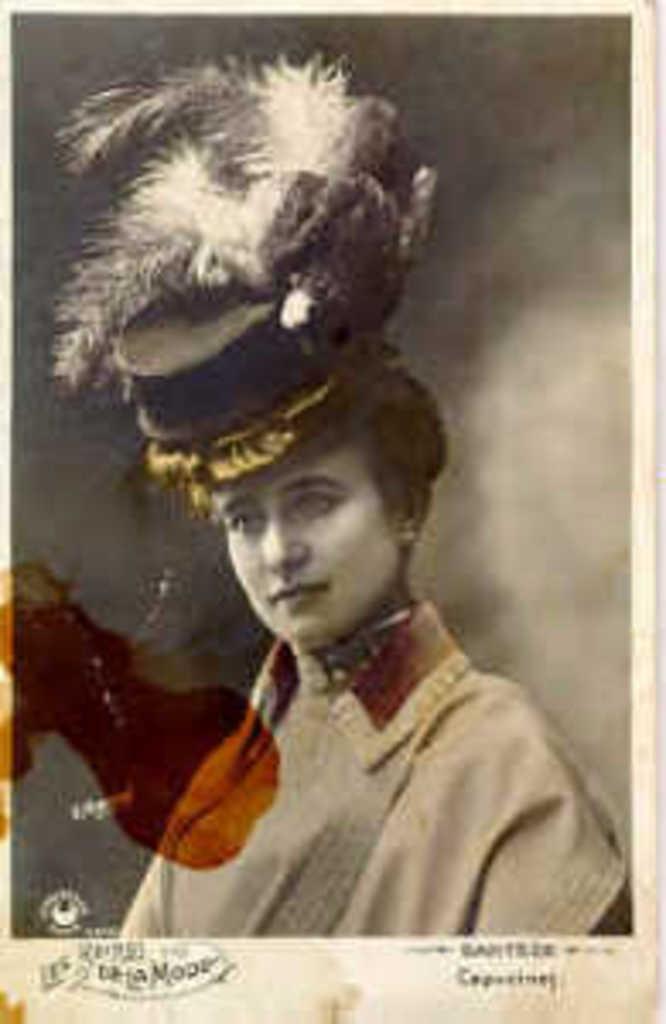Describe this image in one or two sentences. In the picture there is an old photograph of a woman present. 